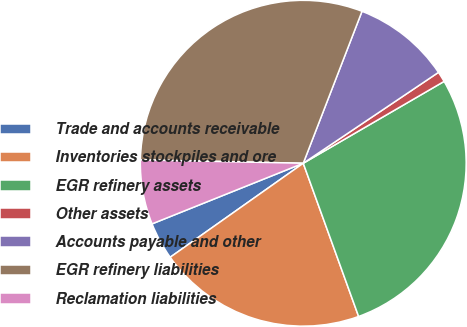<chart> <loc_0><loc_0><loc_500><loc_500><pie_chart><fcel>Trade and accounts receivable<fcel>Inventories stockpiles and ore<fcel>EGR refinery assets<fcel>Other assets<fcel>Accounts payable and other<fcel>EGR refinery liabilities<fcel>Reclamation liabilities<nl><fcel>3.72%<fcel>20.73%<fcel>27.86%<fcel>1.04%<fcel>9.71%<fcel>30.54%<fcel>6.4%<nl></chart> 